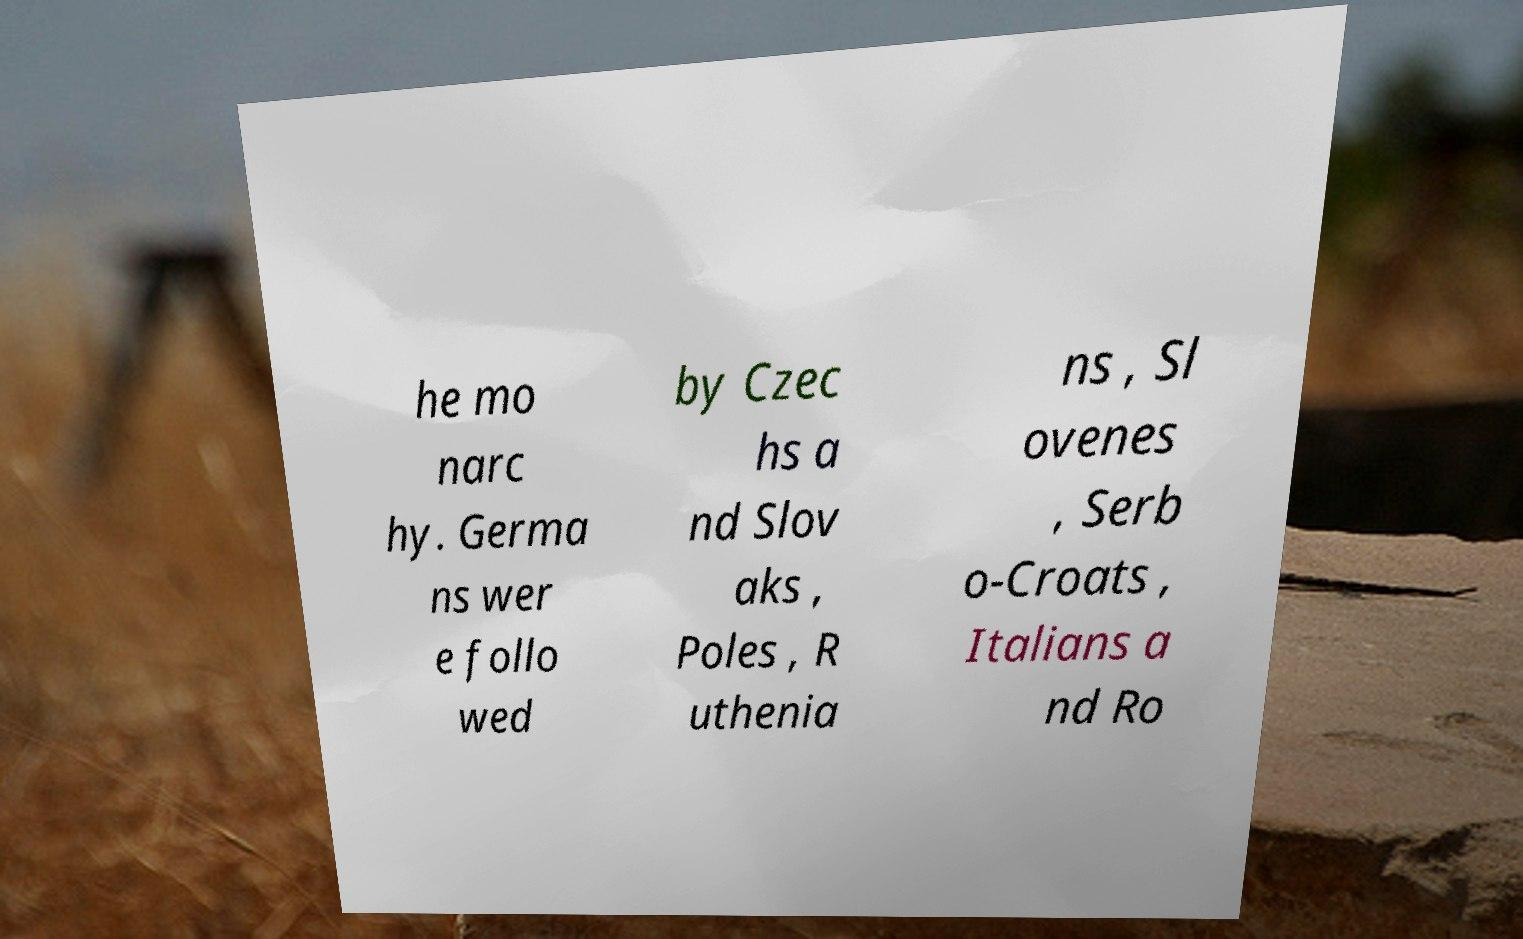Please identify and transcribe the text found in this image. he mo narc hy. Germa ns wer e follo wed by Czec hs a nd Slov aks , Poles , R uthenia ns , Sl ovenes , Serb o-Croats , Italians a nd Ro 